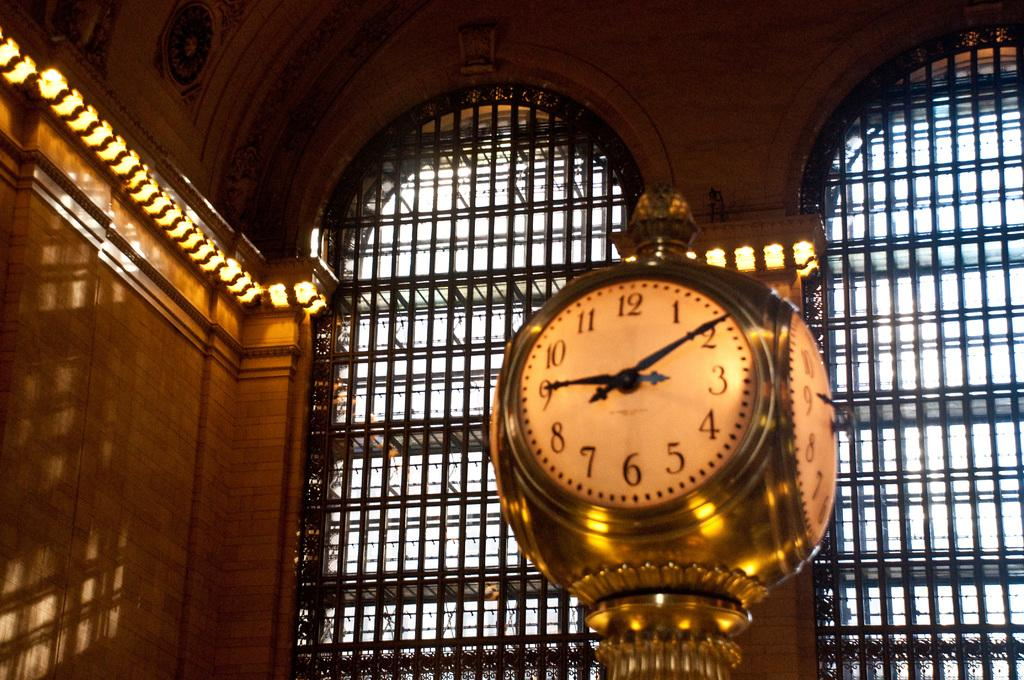Provide a one-sentence caption for the provided image. A golden clock in a station shows that the time is now 9:09. 